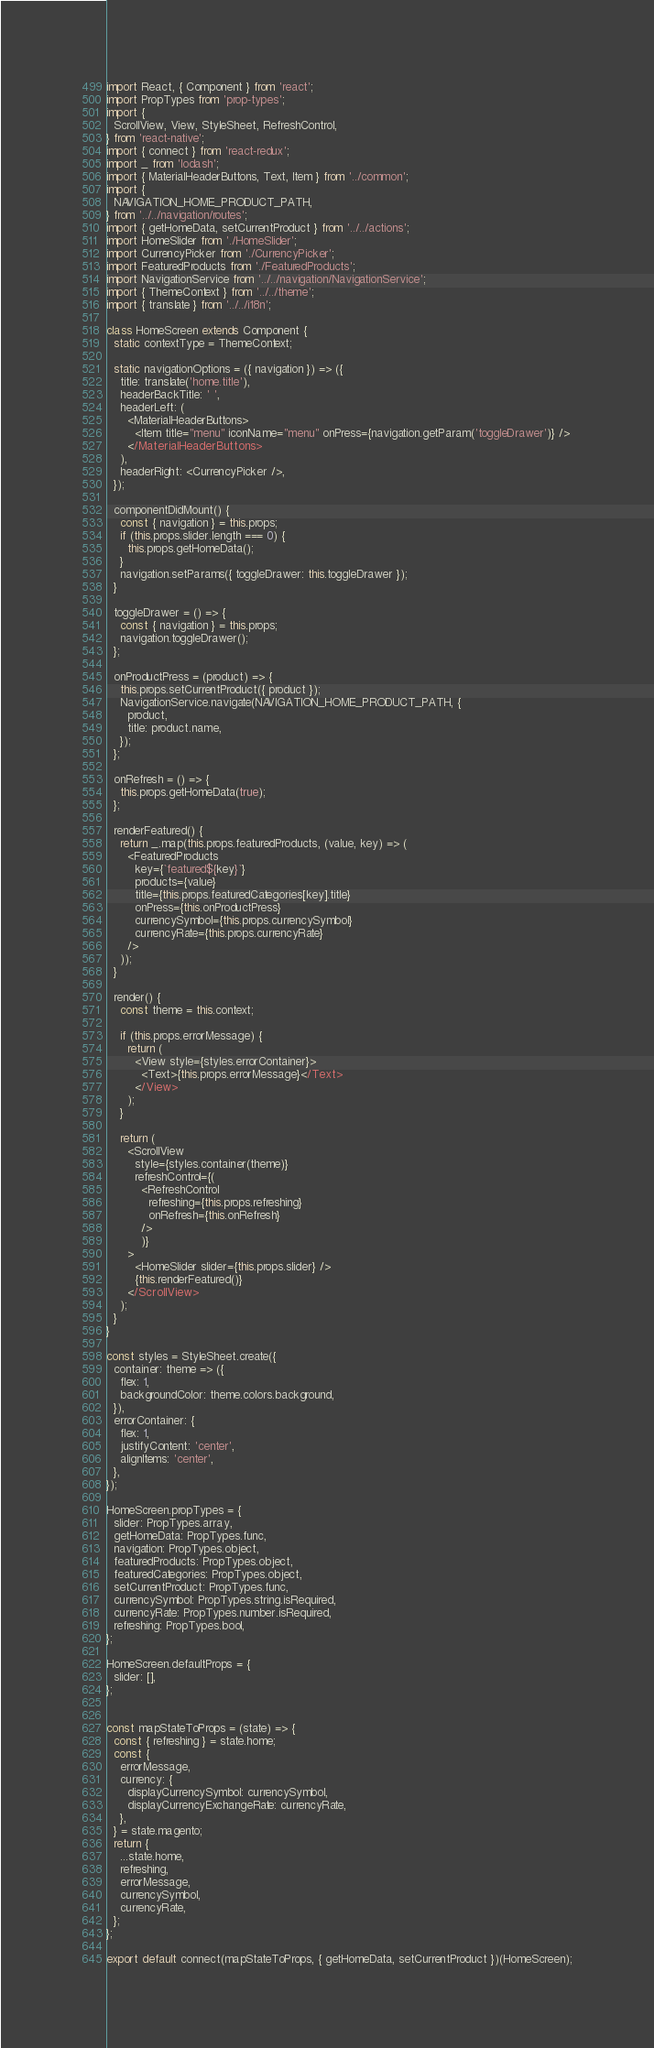Convert code to text. <code><loc_0><loc_0><loc_500><loc_500><_JavaScript_>import React, { Component } from 'react';
import PropTypes from 'prop-types';
import {
  ScrollView, View, StyleSheet, RefreshControl,
} from 'react-native';
import { connect } from 'react-redux';
import _ from 'lodash';
import { MaterialHeaderButtons, Text, Item } from '../common';
import {
  NAVIGATION_HOME_PRODUCT_PATH,
} from '../../navigation/routes';
import { getHomeData, setCurrentProduct } from '../../actions';
import HomeSlider from './HomeSlider';
import CurrencyPicker from './CurrencyPicker';
import FeaturedProducts from './FeaturedProducts';
import NavigationService from '../../navigation/NavigationService';
import { ThemeContext } from '../../theme';
import { translate } from '../../i18n';

class HomeScreen extends Component {
  static contextType = ThemeContext;

  static navigationOptions = ({ navigation }) => ({
    title: translate('home.title'),
    headerBackTitle: ' ',
    headerLeft: (
      <MaterialHeaderButtons>
        <Item title="menu" iconName="menu" onPress={navigation.getParam('toggleDrawer')} />
      </MaterialHeaderButtons>
    ),
    headerRight: <CurrencyPicker />,
  });

  componentDidMount() {
    const { navigation } = this.props;
    if (this.props.slider.length === 0) {
      this.props.getHomeData();
    }
    navigation.setParams({ toggleDrawer: this.toggleDrawer });
  }

  toggleDrawer = () => {
    const { navigation } = this.props;
    navigation.toggleDrawer();
  };

  onProductPress = (product) => {
    this.props.setCurrentProduct({ product });
    NavigationService.navigate(NAVIGATION_HOME_PRODUCT_PATH, {
      product,
      title: product.name,
    });
  };

  onRefresh = () => {
    this.props.getHomeData(true);
  };

  renderFeatured() {
    return _.map(this.props.featuredProducts, (value, key) => (
      <FeaturedProducts
        key={`featured${key}`}
        products={value}
        title={this.props.featuredCategories[key].title}
        onPress={this.onProductPress}
        currencySymbol={this.props.currencySymbol}
        currencyRate={this.props.currencyRate}
      />
    ));
  }

  render() {
    const theme = this.context;

    if (this.props.errorMessage) {
      return (
        <View style={styles.errorContainer}>
          <Text>{this.props.errorMessage}</Text>
        </View>
      );
    }

    return (
      <ScrollView
        style={styles.container(theme)}
        refreshControl={(
          <RefreshControl
            refreshing={this.props.refreshing}
            onRefresh={this.onRefresh}
          />
          )}
      >
        <HomeSlider slider={this.props.slider} />
        {this.renderFeatured()}
      </ScrollView>
    );
  }
}

const styles = StyleSheet.create({
  container: theme => ({
    flex: 1,
    backgroundColor: theme.colors.background,
  }),
  errorContainer: {
    flex: 1,
    justifyContent: 'center',
    alignItems: 'center',
  },
});

HomeScreen.propTypes = {
  slider: PropTypes.array,
  getHomeData: PropTypes.func,
  navigation: PropTypes.object,
  featuredProducts: PropTypes.object,
  featuredCategories: PropTypes.object,
  setCurrentProduct: PropTypes.func,
  currencySymbol: PropTypes.string.isRequired,
  currencyRate: PropTypes.number.isRequired,
  refreshing: PropTypes.bool,
};

HomeScreen.defaultProps = {
  slider: [],
};


const mapStateToProps = (state) => {
  const { refreshing } = state.home;
  const {
    errorMessage,
    currency: {
      displayCurrencySymbol: currencySymbol,
      displayCurrencyExchangeRate: currencyRate,
    },
  } = state.magento;
  return {
    ...state.home,
    refreshing,
    errorMessage,
    currencySymbol,
    currencyRate,
  };
};

export default connect(mapStateToProps, { getHomeData, setCurrentProduct })(HomeScreen);
</code> 